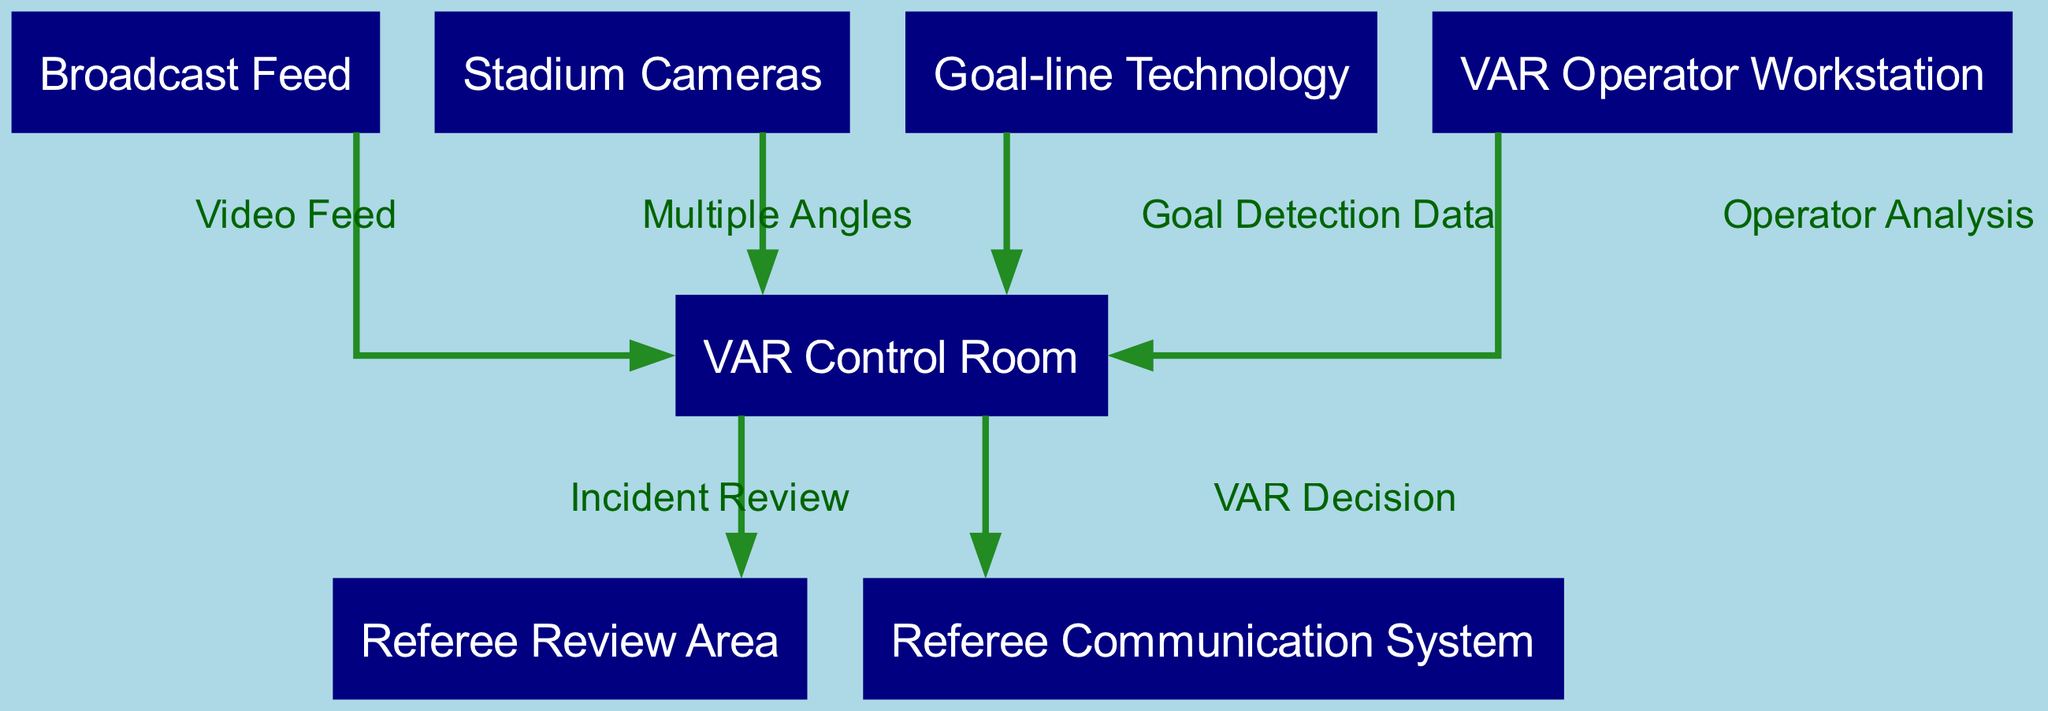What is the total number of nodes in the diagram? The diagram lists a total of seven nodes: VAR Control Room, Referee Review Area, Broadcast Feed, Stadium Cameras, Goal-line Technology, Referee Communication System, and VAR Operator Workstation. Counting these gives us 7.
Answer: 7 What does the VAR Control Room receive from the Broadcast Feed? According to the edge labeled "Video Feed," the VAR Control Room receives a video feed from the Broadcast Feed, which connects these two nodes interactively.
Answer: Video Feed Which node connects the VAR Control Room to the Referee Review Area? The connection from the VAR Control Room to the Referee Review Area is labeled "Incident Review," indicated clearly by the directed edge that connects these two nodes.
Answer: Incident Review How many edges are present in the diagram? By examining the edges listed in the diagram, there are a total of six connections between nodes: from Broadcast Feed to VAR Control Room, Stadium Cameras to VAR Control Room, Goal-line Technology to VAR Control Room, VAR Control Room to Referee Review Area, VAR Control Room to Referee Communication System, and VAR Operator Workstation to VAR Control Room. This totals to 6 edges.
Answer: 6 What type of data does the Goal-line Technology provide to the VAR Control Room? The edge labeled "Goal Detection Data," shows that the Goal-line Technology provides specific data related to goal detection to the VAR Control Room, which is essential for decision-making in the context of the game.
Answer: Goal Detection Data Explain the flow of information from the VAR Operator Workstation to the VAR Control Room. The VAR Operator Workstation sends analysis to the VAR Control Room as shown by the edge labeled "Operator Analysis." This indicates that the operator provides insights or evaluations of incidents through this connection, contributing to the control room's decisions.
Answer: Operator Analysis What is the relationship between the VAR Control Room and the Referee Communication System? The relationship is indicated by the connection labeled "VAR Decision," showing that decisions made in the VAR Control Room are communicated to the Referee Communication System. This is crucial for ensuring that on-field referees receive timely and accurate decisions.
Answer: VAR Decision Which node is responsible for providing multiple camera angles to the VAR Control Room? The node labeled "Stadium Cameras" is responsible for providing multiple angles, which is indicated by the edge that connects it to the VAR Control Room and is labeled "Multiple Angles." This information is vital for the VAR process.
Answer: Stadium Cameras 